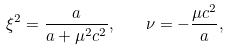Convert formula to latex. <formula><loc_0><loc_0><loc_500><loc_500>\xi ^ { 2 } = \frac { a } { a + \mu ^ { 2 } c ^ { 2 } } , \quad \nu = - \frac { \mu c ^ { 2 } } { a } ,</formula> 